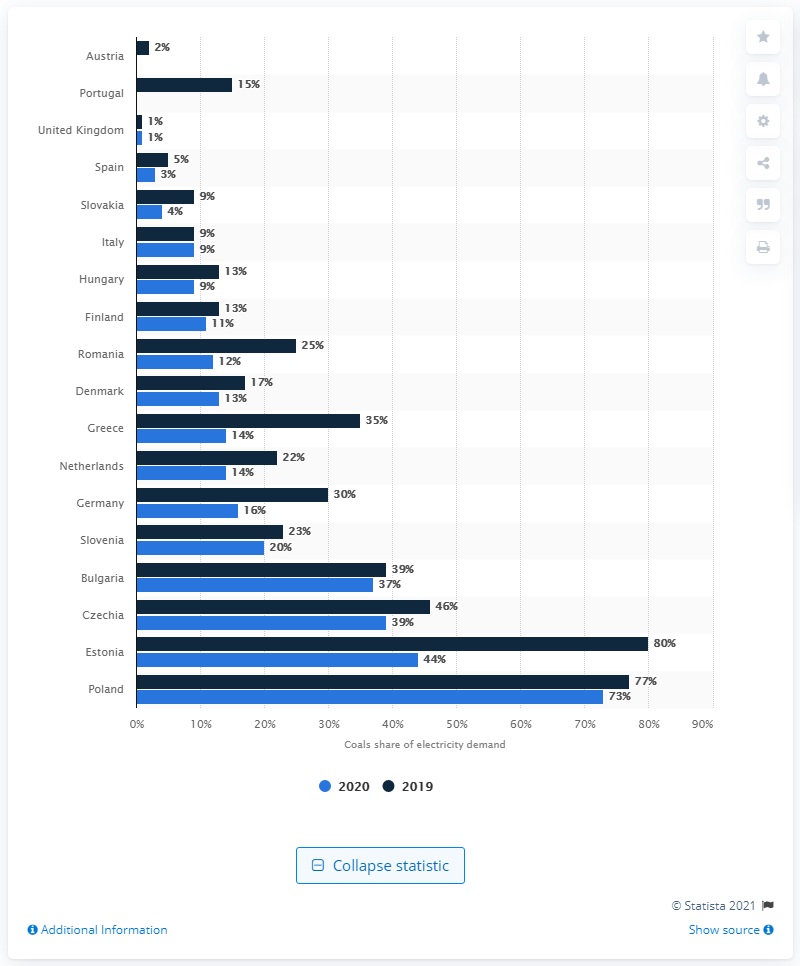Outline some significant characteristics in this image. In 2020, the demand for coal in Germany's energy mix was 16%. 